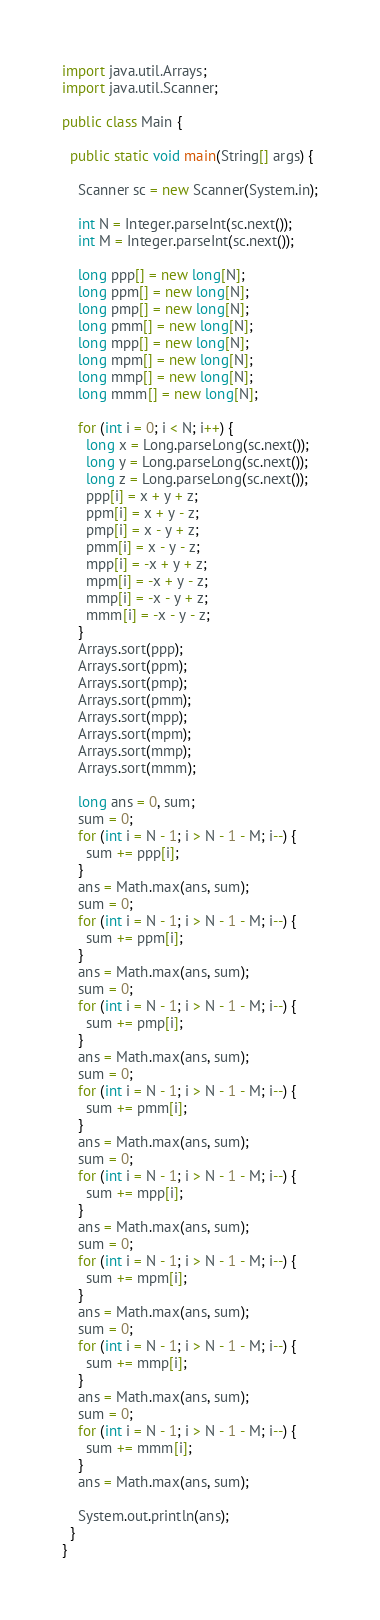Convert code to text. <code><loc_0><loc_0><loc_500><loc_500><_Java_>import java.util.Arrays;
import java.util.Scanner;

public class Main {

  public static void main(String[] args) {

    Scanner sc = new Scanner(System.in);

    int N = Integer.parseInt(sc.next());
    int M = Integer.parseInt(sc.next());

    long ppp[] = new long[N];
    long ppm[] = new long[N];
    long pmp[] = new long[N];
    long pmm[] = new long[N];
    long mpp[] = new long[N];
    long mpm[] = new long[N];
    long mmp[] = new long[N];
    long mmm[] = new long[N];

    for (int i = 0; i < N; i++) {
      long x = Long.parseLong(sc.next());
      long y = Long.parseLong(sc.next());
      long z = Long.parseLong(sc.next());
      ppp[i] = x + y + z;
      ppm[i] = x + y - z;
      pmp[i] = x - y + z;
      pmm[i] = x - y - z;
      mpp[i] = -x + y + z;
      mpm[i] = -x + y - z;
      mmp[i] = -x - y + z;
      mmm[i] = -x - y - z;
    }
    Arrays.sort(ppp);
    Arrays.sort(ppm);
    Arrays.sort(pmp);
    Arrays.sort(pmm);
    Arrays.sort(mpp);
    Arrays.sort(mpm);
    Arrays.sort(mmp);
    Arrays.sort(mmm);

    long ans = 0, sum;
    sum = 0;
    for (int i = N - 1; i > N - 1 - M; i--) {
      sum += ppp[i];
    }
    ans = Math.max(ans, sum);
    sum = 0;
    for (int i = N - 1; i > N - 1 - M; i--) {
      sum += ppm[i];
    }
    ans = Math.max(ans, sum);
    sum = 0;
    for (int i = N - 1; i > N - 1 - M; i--) {
      sum += pmp[i];
    }
    ans = Math.max(ans, sum);
    sum = 0;
    for (int i = N - 1; i > N - 1 - M; i--) {
      sum += pmm[i];
    }
    ans = Math.max(ans, sum);
    sum = 0;
    for (int i = N - 1; i > N - 1 - M; i--) {
      sum += mpp[i];
    }
    ans = Math.max(ans, sum);
    sum = 0;
    for (int i = N - 1; i > N - 1 - M; i--) {
      sum += mpm[i];
    }
    ans = Math.max(ans, sum);
    sum = 0;
    for (int i = N - 1; i > N - 1 - M; i--) {
      sum += mmp[i];
    }
    ans = Math.max(ans, sum);
    sum = 0;
    for (int i = N - 1; i > N - 1 - M; i--) {
      sum += mmm[i];
    }
    ans = Math.max(ans, sum);

    System.out.println(ans);
  }
}</code> 